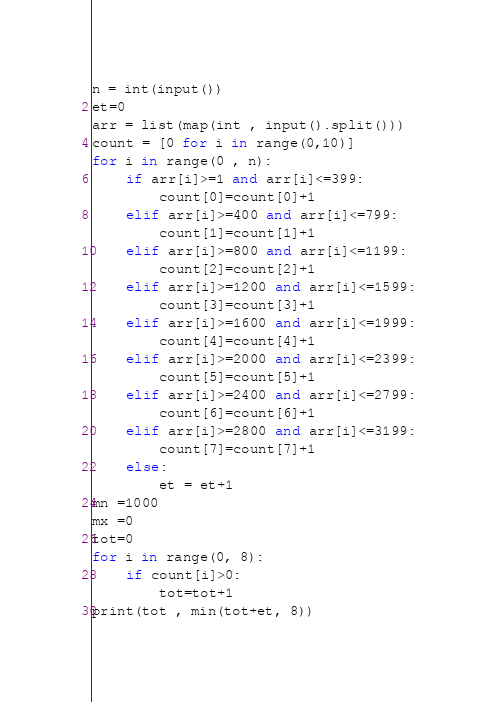Convert code to text. <code><loc_0><loc_0><loc_500><loc_500><_Python_>n = int(input())
et=0
arr = list(map(int , input().split()))
count = [0 for i in range(0,10)]
for i in range(0 , n):
	if arr[i]>=1 and arr[i]<=399:
		count[0]=count[0]+1
	elif arr[i]>=400 and arr[i]<=799:
		count[1]=count[1]+1
	elif arr[i]>=800 and arr[i]<=1199:
		count[2]=count[2]+1
	elif arr[i]>=1200 and arr[i]<=1599:
		count[3]=count[3]+1
	elif arr[i]>=1600 and arr[i]<=1999:
		count[4]=count[4]+1
	elif arr[i]>=2000 and arr[i]<=2399:
		count[5]=count[5]+1
	elif arr[i]>=2400 and arr[i]<=2799:
		count[6]=count[6]+1
	elif arr[i]>=2800 and arr[i]<=3199:
		count[7]=count[7]+1
	else:
		et = et+1
mn =1000
mx =0
tot=0
for i in range(0, 8):
	if count[i]>0:
		tot=tot+1
print(tot , min(tot+et, 8))
</code> 